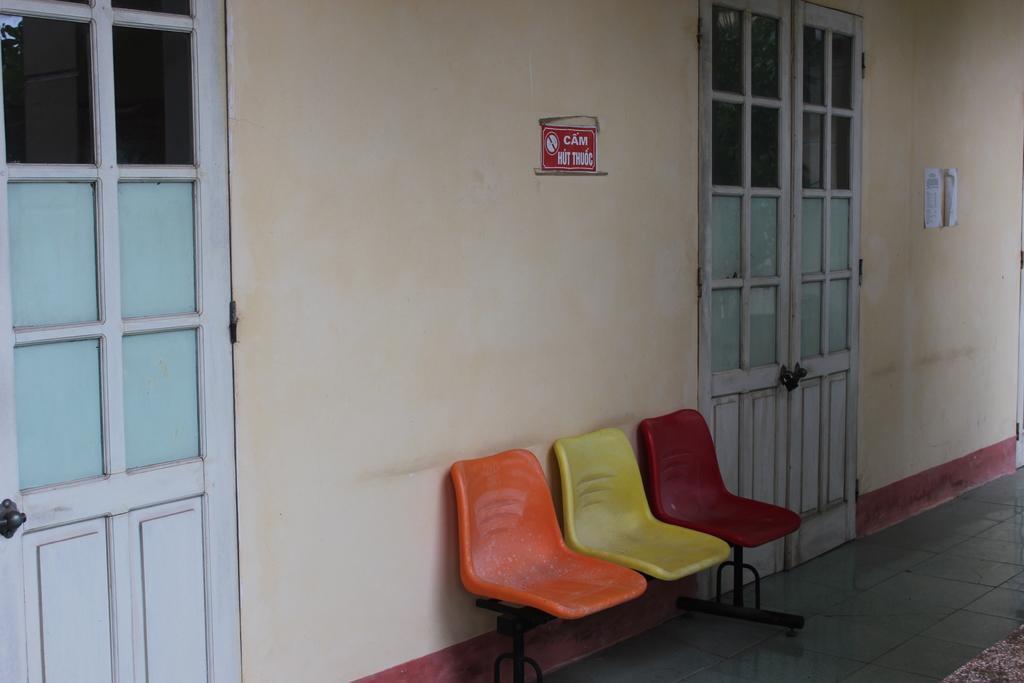Can you describe this image briefly? We can see chairs on the surface and we can see doors,floor and wall. 